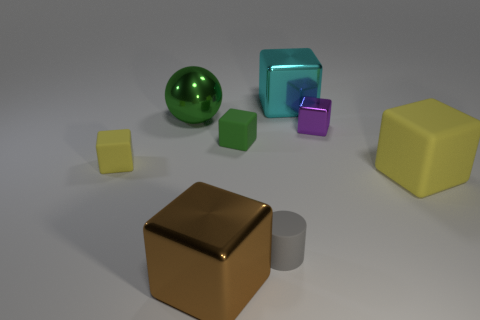Subtract 3 cubes. How many cubes are left? 3 Subtract all cyan cubes. How many cubes are left? 5 Subtract all large cyan cubes. How many cubes are left? 5 Subtract all purple blocks. Subtract all gray cylinders. How many blocks are left? 5 Add 1 large green cubes. How many objects exist? 9 Subtract all spheres. How many objects are left? 7 Subtract 0 purple cylinders. How many objects are left? 8 Subtract all big metallic spheres. Subtract all big yellow matte blocks. How many objects are left? 6 Add 4 big green balls. How many big green balls are left? 5 Add 7 small green matte objects. How many small green matte objects exist? 8 